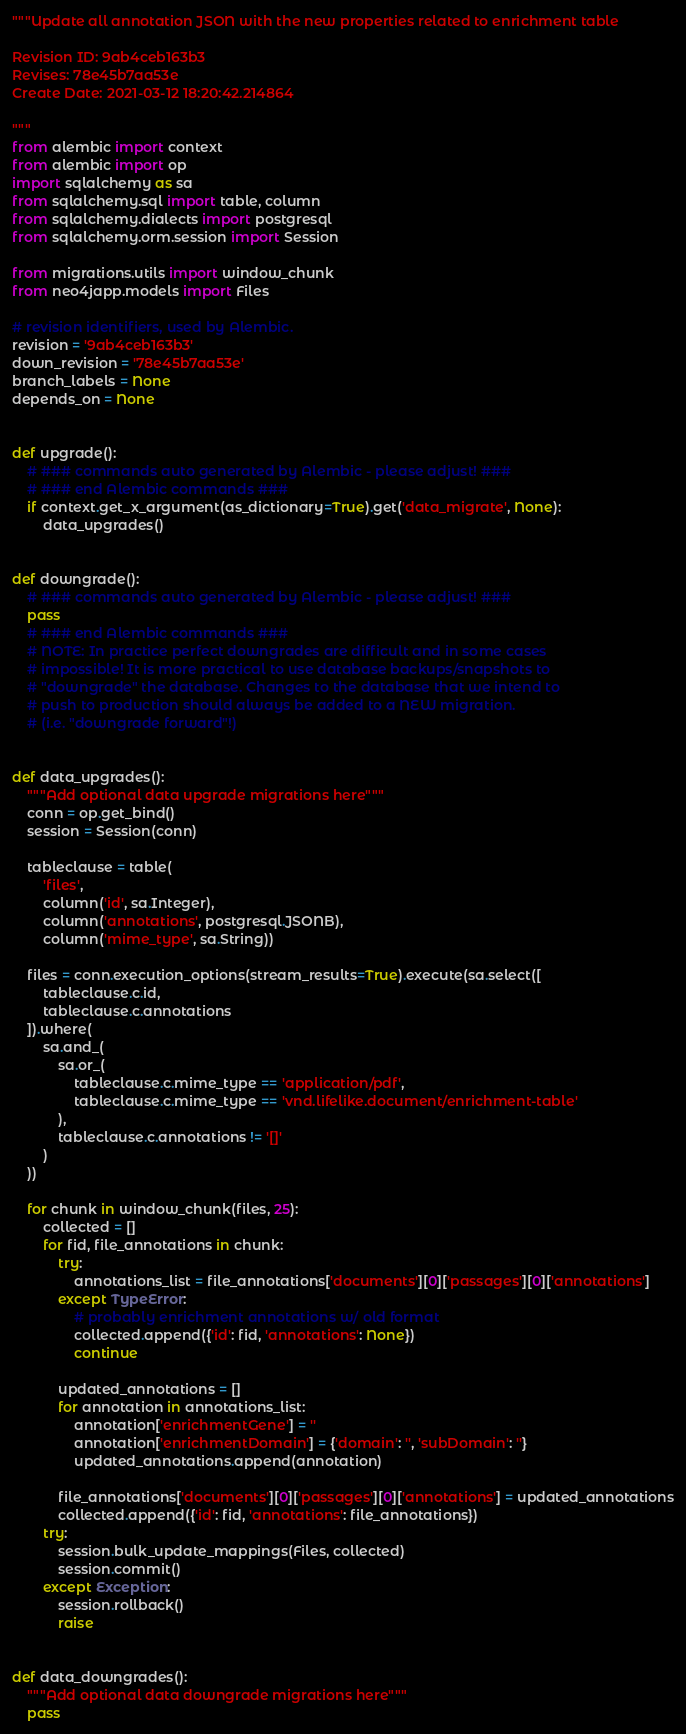<code> <loc_0><loc_0><loc_500><loc_500><_Python_>"""Update all annotation JSON with the new properties related to enrichment table

Revision ID: 9ab4ceb163b3
Revises: 78e45b7aa53e
Create Date: 2021-03-12 18:20:42.214864

"""
from alembic import context
from alembic import op
import sqlalchemy as sa
from sqlalchemy.sql import table, column
from sqlalchemy.dialects import postgresql
from sqlalchemy.orm.session import Session

from migrations.utils import window_chunk
from neo4japp.models import Files

# revision identifiers, used by Alembic.
revision = '9ab4ceb163b3'
down_revision = '78e45b7aa53e'
branch_labels = None
depends_on = None


def upgrade():
    # ### commands auto generated by Alembic - please adjust! ###
    # ### end Alembic commands ###
    if context.get_x_argument(as_dictionary=True).get('data_migrate', None):
        data_upgrades()


def downgrade():
    # ### commands auto generated by Alembic - please adjust! ###
    pass
    # ### end Alembic commands ###
    # NOTE: In practice perfect downgrades are difficult and in some cases
    # impossible! It is more practical to use database backups/snapshots to
    # "downgrade" the database. Changes to the database that we intend to
    # push to production should always be added to a NEW migration.
    # (i.e. "downgrade forward"!)


def data_upgrades():
    """Add optional data upgrade migrations here"""
    conn = op.get_bind()
    session = Session(conn)

    tableclause = table(
        'files',
        column('id', sa.Integer),
        column('annotations', postgresql.JSONB),
        column('mime_type', sa.String))

    files = conn.execution_options(stream_results=True).execute(sa.select([
        tableclause.c.id,
        tableclause.c.annotations
    ]).where(
        sa.and_(
            sa.or_(
                tableclause.c.mime_type == 'application/pdf',
                tableclause.c.mime_type == 'vnd.lifelike.document/enrichment-table'
            ),
            tableclause.c.annotations != '[]'
        )
    ))

    for chunk in window_chunk(files, 25):
        collected = []
        for fid, file_annotations in chunk:
            try:
                annotations_list = file_annotations['documents'][0]['passages'][0]['annotations']
            except TypeError:
                # probably enrichment annotations w/ old format
                collected.append({'id': fid, 'annotations': None})
                continue

            updated_annotations = []
            for annotation in annotations_list:
                annotation['enrichmentGene'] = ''
                annotation['enrichmentDomain'] = {'domain': '', 'subDomain': ''}
                updated_annotations.append(annotation)

            file_annotations['documents'][0]['passages'][0]['annotations'] = updated_annotations
            collected.append({'id': fid, 'annotations': file_annotations})
        try:
            session.bulk_update_mappings(Files, collected)
            session.commit()
        except Exception:
            session.rollback()
            raise


def data_downgrades():
    """Add optional data downgrade migrations here"""
    pass
</code> 